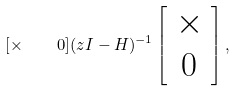<formula> <loc_0><loc_0><loc_500><loc_500>[ \times \quad 0 ] ( z I - H ) ^ { - 1 } \left [ \begin{array} { c } \times \\ 0 \end{array} \right ] ,</formula> 